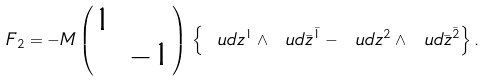<formula> <loc_0><loc_0><loc_500><loc_500>F _ { 2 } = - M \begin{pmatrix} 1 & \\ & - 1 \end{pmatrix} \, \left \{ \ u d z ^ { 1 } \wedge \ u d \bar { z } ^ { \bar { 1 } } - \ u d z ^ { 2 } \wedge \ u d \bar { z } ^ { \bar { 2 } } \right \} .</formula> 